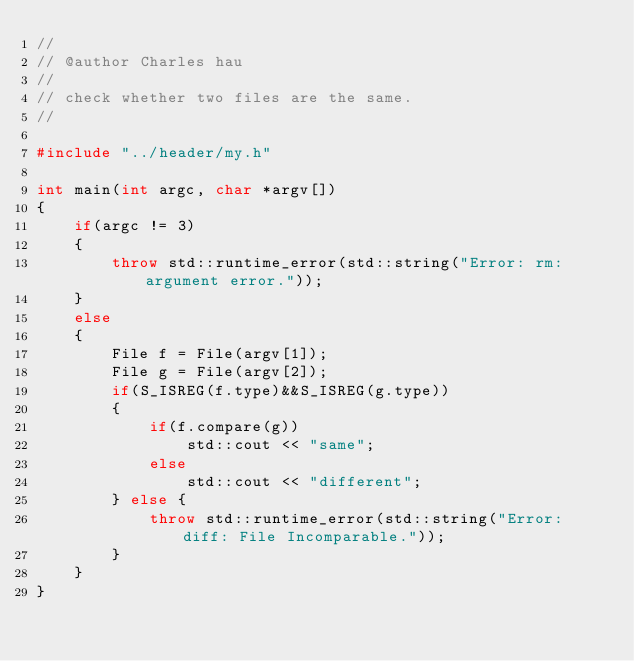<code> <loc_0><loc_0><loc_500><loc_500><_C++_>//
// @author Charles hau
// 
// check whether two files are the same.
//

#include "../header/my.h"

int main(int argc, char *argv[])
{
	if(argc != 3)
	{
		throw std::runtime_error(std::string("Error: rm: argument error."));
	}
	else
	{
		File f = File(argv[1]);
		File g = File(argv[2]);
		if(S_ISREG(f.type)&&S_ISREG(g.type))
		{
			if(f.compare(g))
				std::cout << "same";
			else
				std::cout << "different";
		} else {
			throw std::runtime_error(std::string("Error: diff: File Incomparable."));
		}
	}
}</code> 